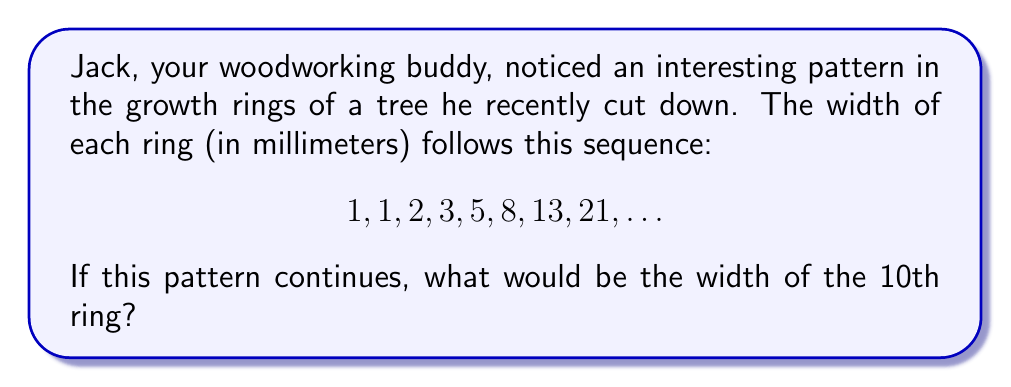Help me with this question. Let's approach this step-by-step:

1) First, we need to recognize the pattern in the given sequence. This is a Fibonacci-like sequence, where each number is the sum of the two preceding ones.

2) Let's write out the sequence and check:
   $1, 1, 2, 3, 5, 8, 13, 21, ...$

3) We can verify:
   $1 + 1 = 2$
   $1 + 2 = 3$
   $2 + 3 = 5$
   $3 + 5 = 8$
   $5 + 8 = 13$
   $8 + 13 = 21$

4) Now, we need to continue this pattern to find the 9th and 10th terms:

   9th term: $13 + 21 = 34$
   10th term: $21 + 34 = 55$

5) Therefore, if this pattern continues, the width of the 10th ring would be 55 mm.

This sequence mimics the Fibonacci sequence, which is often found in nature, including tree growth patterns. As a carpenter, Jack would appreciate how mathematics can describe natural phenomena!
Answer: 55 mm 